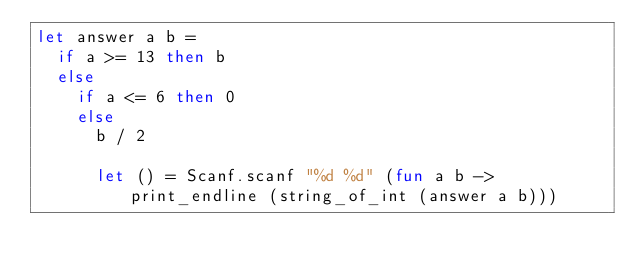Convert code to text. <code><loc_0><loc_0><loc_500><loc_500><_OCaml_>let answer a b =
  if a >= 13 then b
  else
    if a <= 6 then 0
    else
      b / 2

      let () = Scanf.scanf "%d %d" (fun a b -> print_endline (string_of_int (answer a b)))
</code> 